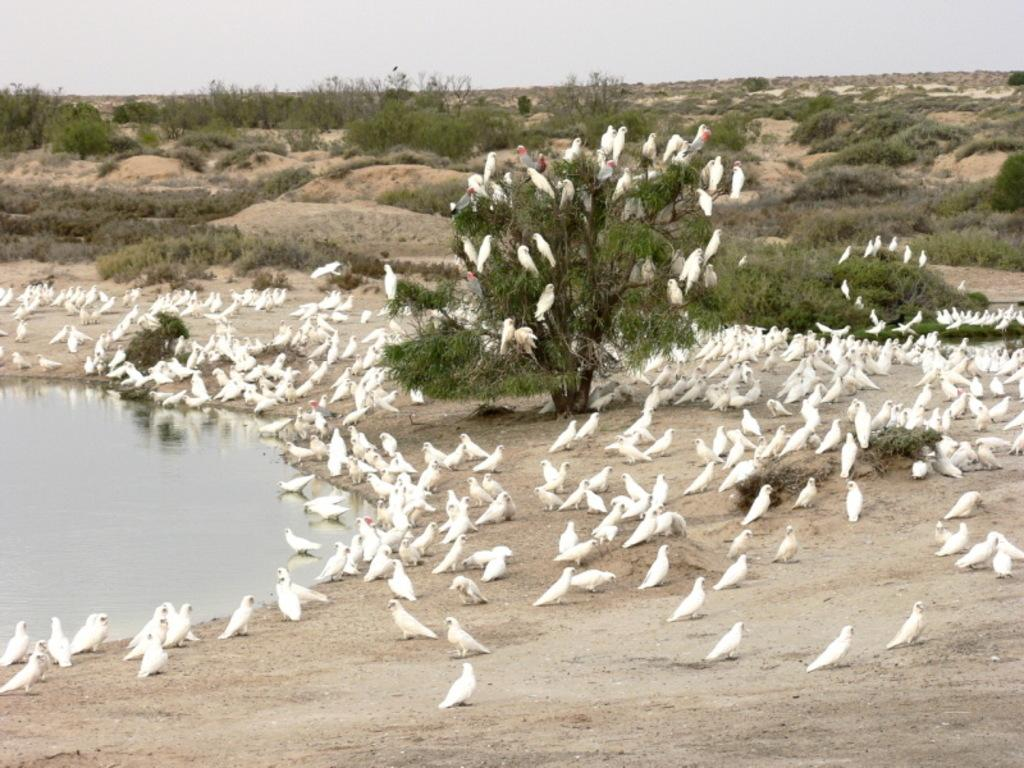What type of animals can be seen in the image? There are many birds in the image. What type of terrain is visible in the image? There is soil, water, and grass visible in the image. What type of plant is present in the image? There is a tree in the image. What part of the natural environment is visible in the image? The sky is visible in the image. What type of cherry is being used to cause a desire for more in the image? There is no cherry present in the image, and therefore no such cause and desire can be observed. 